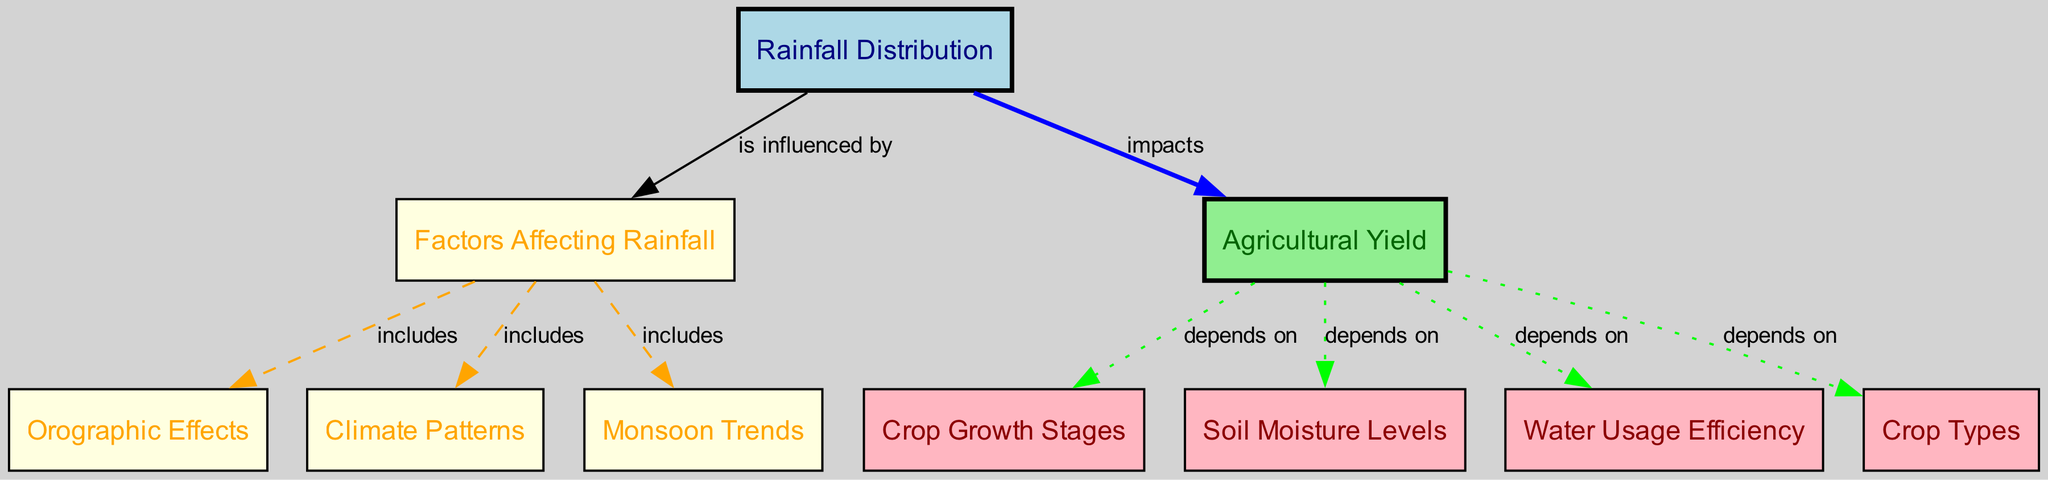What is the primary factor influencing rainfall distribution? The diagram indicates that "Rainfall Distribution" is influenced by "Factors Affecting Rainfall."
Answer: Factors Affecting Rainfall How many nodes are present in the diagram? By counting the entries in the "nodes" section of the data, there are a total of 10 distinct nodes.
Answer: 10 Which node is directly connected to "Agricultural Yield"? The edge from "Agricultural Yield" shows that it directly depends on "Crop Growth Stages," "Soil Moisture Levels," "Water Usage Efficiency," and "Crop Types," making these the connected nodes.
Answer: Crop Growth Stages, Soil Moisture Levels, Water Usage Efficiency, Crop Types What color represents "Rainfall Distribution" in the diagram? The node representing "Rainfall Distribution" is filled with light blue color, indicating its unique position in the diagram.
Answer: Light blue Which climate-related factors are included under "Factors Affecting Rainfall"? The connections to "Factors Affecting Rainfall" include "Orographic Effects," "Climate Patterns," and "Monsoon Trends."
Answer: Orographic Effects, Climate Patterns, Monsoon Trends How does rainfall distribution impact agricultural yield? According to the diagram, rainfall distribution impacts agricultural yield directly, signifying a one-way relationship where variation in rainfall directly affects yield outcomes.
Answer: Impacts What determines agricultural yield according to the diagram? The diagram illustrates that agricultural yield depends on crop growth stages, soil moisture levels, water usage efficiency, and crop types.
Answer: Crop Growth Stages, Soil Moisture Levels, Water Usage Efficiency, Crop Types Which node connects "Rainfall Distribution" to "Agricultural Yield"? The diagram illustrates a direct connection depicting that "Rainfall Distribution" impacts "Agricultural Yield." This indicates an influence from one concept to another.
Answer: Agricultural Yield What is the relationship between "Agricultural Yield" and "Soil Moisture Levels"? The connection in the diagram indicates that "Agricultural Yield" depends on "Soil Moisture Levels," signifying that changes in soil moisture levels will directly affect yield outcomes.
Answer: Depends on 